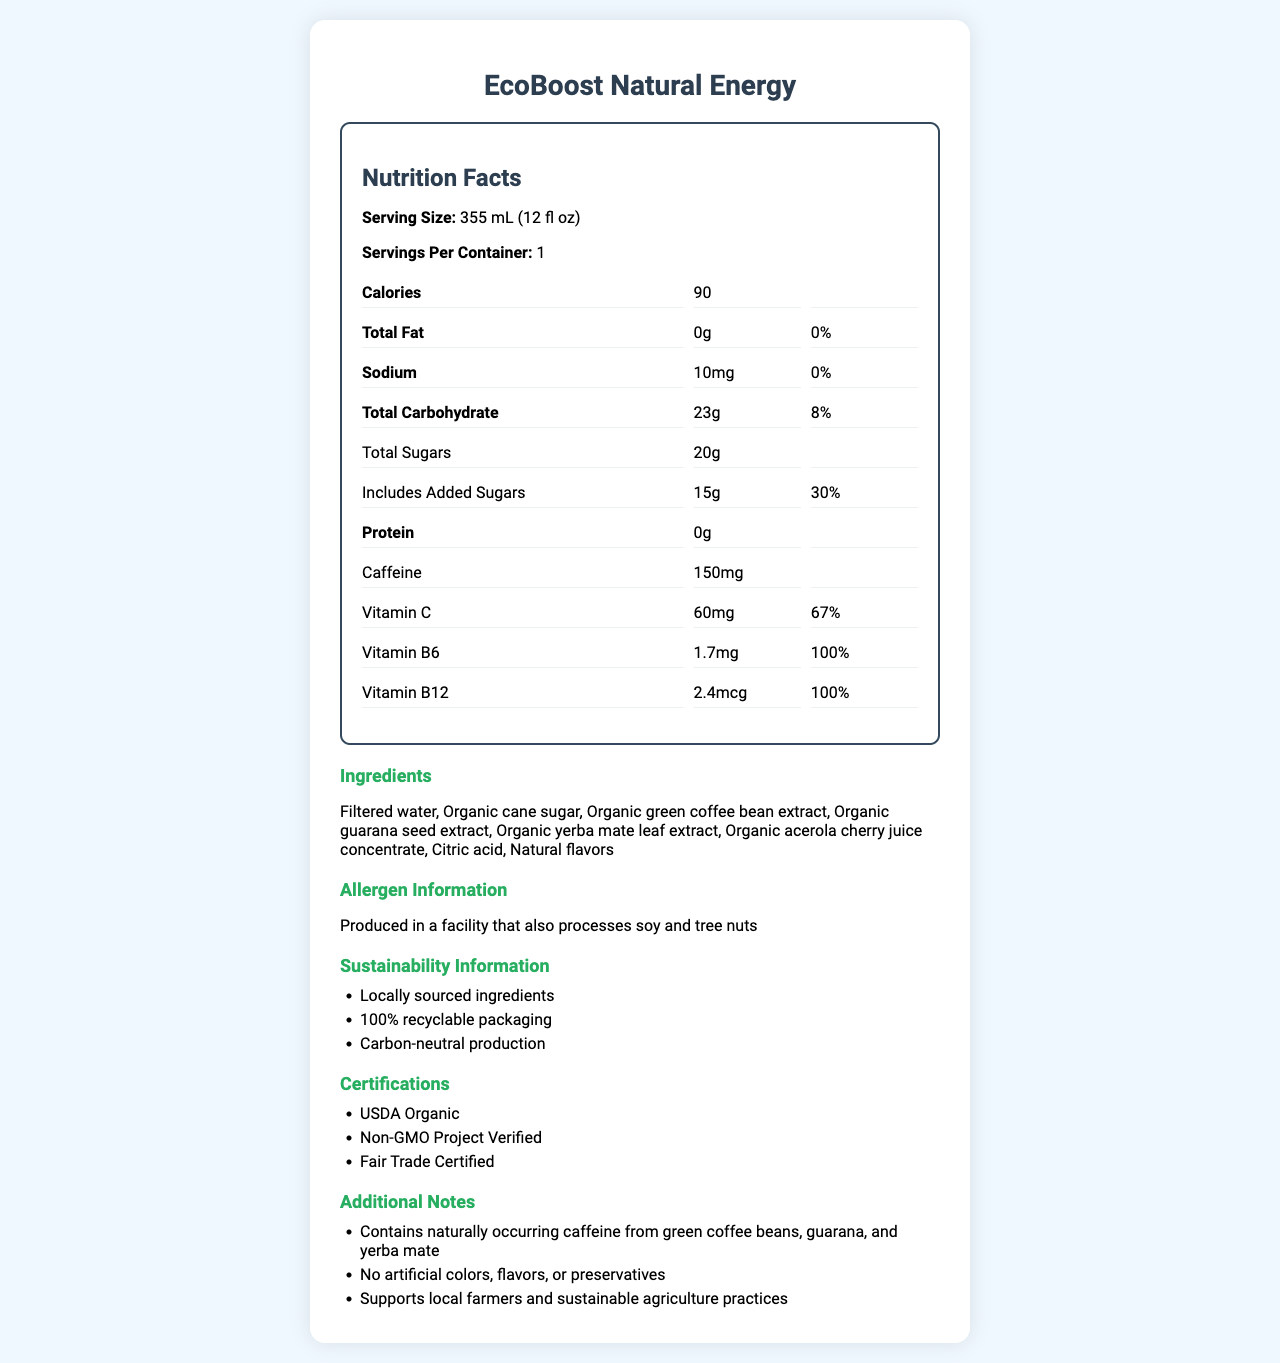what is the serving size of EcoBoost Natural Energy? The serving size is listed at the top of the Nutrition Facts as "Serving Size: 355 mL (12 fl oz)".
Answer: 355 mL (12 fl oz) how many calories are in one serving of EcoBoost Natural Energy? The calorie content per serving is found in the Nutrition Facts section and is stated as 90 calories.
Answer: 90 what are the main sources of natural caffeine in EcoBoost Natural Energy? The additional notes section mentions that it contains naturally occurring caffeine from green coffee beans, guarana, and yerba mate.
Answer: green coffee beans, guarana, yerba mate how much vitamin C is in one serving and what percentage of the daily value does this represent? The amount of vitamin C per serving is 60mg, which represents 67% of the daily value, as stated in the Nutrition Facts.
Answer: 60mg, 67% what certifications does EcoBoost Natural Energy have? The certifications section lists USDA Organic, Non-GMO Project Verified, and Fair Trade Certified.
Answer: USDA Organic, Non-GMO Project Verified, Fair Trade Certified how much total sugar and added sugar does one serving contain? The Nutrition Facts section mentions that there are 20g of total sugars and 15g of added sugars.
Answer: 20g total sugar, 15g added sugar how much sodium is in EcoBoost Natural Energy? A. 0mg B. 10mg C. 20mg D. 100mg The sodium content per serving is stated as 10mg in the Nutrition Facts.
Answer: B which vitamins are present in 100% of the daily value? A. Vitamin C and Vitamin B6 B. Vitamin B6 and Vitamin B12 C. Vitamin C and Vitamin B12 D. Vitamin A and Vitamin D According to the Nutrition Facts, Vitamin B6 and Vitamin B12 each represent 100% of the daily value per serving.
Answer: B is EcoBoost Natural Energy free from artificial colors, flavors, and preservatives? The additional notes confirm that it has no artificial colors, flavors, or preservatives.
Answer: Yes describe the main idea of the document. The answer summarizes the entire document, focusing on the main points about the product's nutritional content, ingredient sources, certifications, and sustainability practices.
Answer: The document provides the Nutrition Facts, ingredient list, allergen information, sustainability information, certifications, and additional notes about the EcoBoost Natural Energy drink. It highlights its locally-sourced, natural ingredients including natural caffeine sources like green coffee beans, guarana, and yerba mate, its nutritional benefits such as significant amounts of Vitamin C and B vitamins, and its commitment to sustainability and local farmers. what is the daily value percentage of total fats in one serving? The Nutrition Facts section shows that the total fat content per serving is 0 grams, with a daily value percentage of 0%.
Answer: 0% can the exact carbon footprint of the production be determined from the document? The document mentions carbon-neutral production but does not provide specific details or data on the carbon footprint.
Answer: Not enough information 